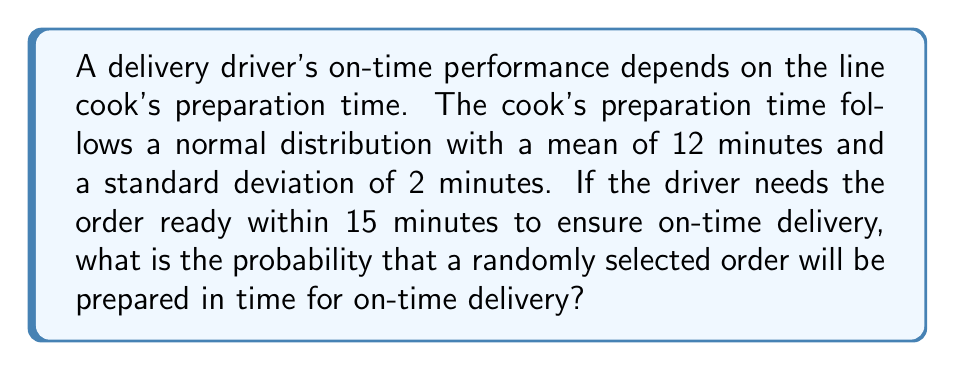Can you solve this math problem? To solve this problem, we need to calculate the probability that the preparation time is less than or equal to 15 minutes, given that it follows a normal distribution with μ = 12 and σ = 2.

Step 1: Calculate the z-score for 15 minutes.
z = (x - μ) / σ
z = (15 - 12) / 2 = 1.5

Step 2: Use the standard normal distribution table or a calculator to find the probability corresponding to z = 1.5.

The area under the standard normal curve to the left of z = 1.5 is approximately 0.9332.

Therefore, the probability that an order will be prepared within 15 minutes is 0.9332 or 93.32%.

This can be expressed mathematically as:

$$P(X \leq 15) = P(Z \leq 1.5) = 0.9332$$

Where X is the preparation time, and Z is the standard normal random variable.
Answer: 0.9332 